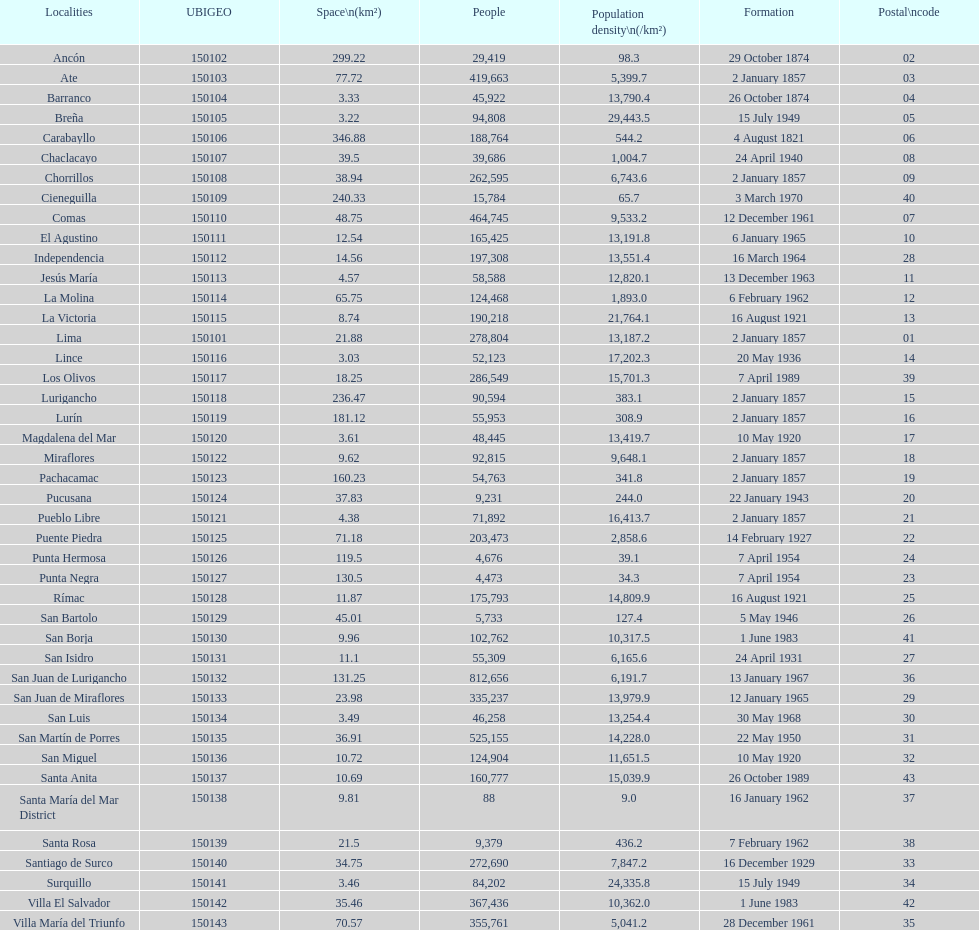What was the last district created? Santa Anita. 